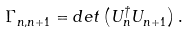<formula> <loc_0><loc_0><loc_500><loc_500>\Gamma ^ { \ } _ { n , n + 1 } = d e t \left ( U ^ { \dag } _ { n } U ^ { \ } _ { n + 1 } \right ) .</formula> 